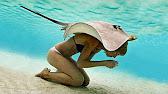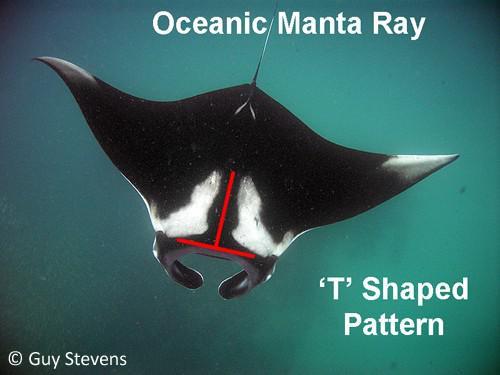The first image is the image on the left, the second image is the image on the right. For the images displayed, is the sentence "There are two manta rays in total." factually correct? Answer yes or no. Yes. The first image is the image on the left, the second image is the image on the right. Analyze the images presented: Is the assertion "An image contains exactly two stingray swimming in blue water with light shining in the scene." valid? Answer yes or no. No. 